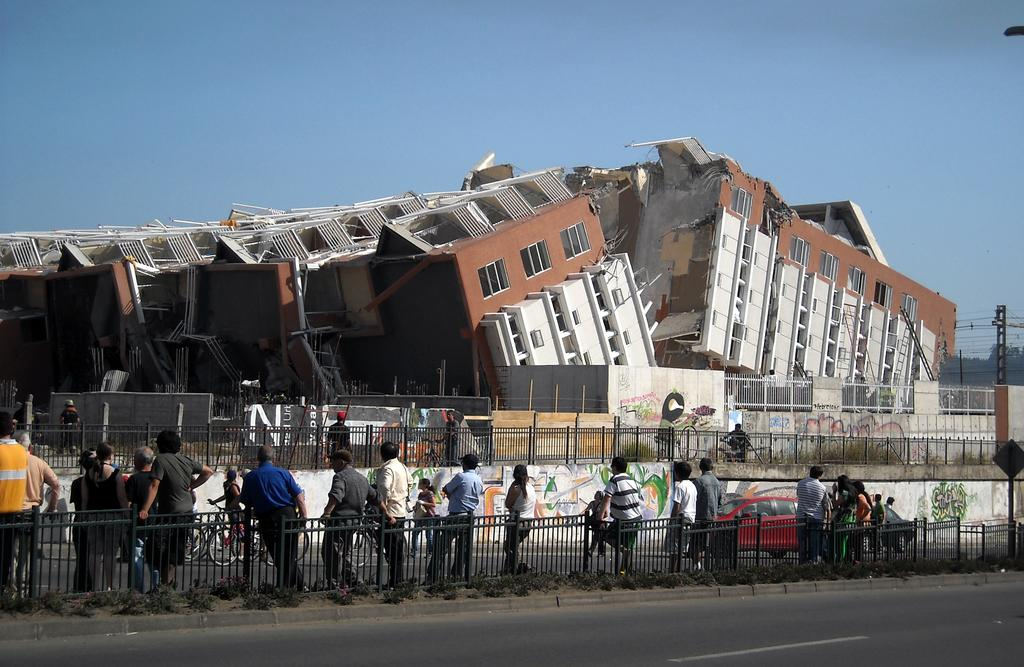What is the main subject of the image? The main subject of the image is a collapsed building. Can you describe the people in the image? There are people in the image, but their specific actions or roles are not clear. What type of barrier can be seen in the image? There is a fence in the image. What type of vehicles are present in the image? There are cars in the image. Are there any other modes of transportation visible in the image? Yes, there are bicycles in the image. What is the purpose of the signboard in the image? The purpose of the signboard in the image is not clear from the facts provided. Can you describe the pole in the far distance of the image? There is a pole in the far distance of the image, but its specific features or purpose are not clear. What type of vegetation can be seen in the far distance of the image? There are trees in the far distance of the image. What is visible in the background of the image? The sky is visible in the background of the image. What type of artwork can be seen on a wall in the image? There is graffiti on a wall in the image. What song is the minister singing in the image? There is no minister or song present in the image. What type of account does the graffiti on the wall represent in the image? The graffiti on the wall is an artistic expression and does not represent any specific account. 